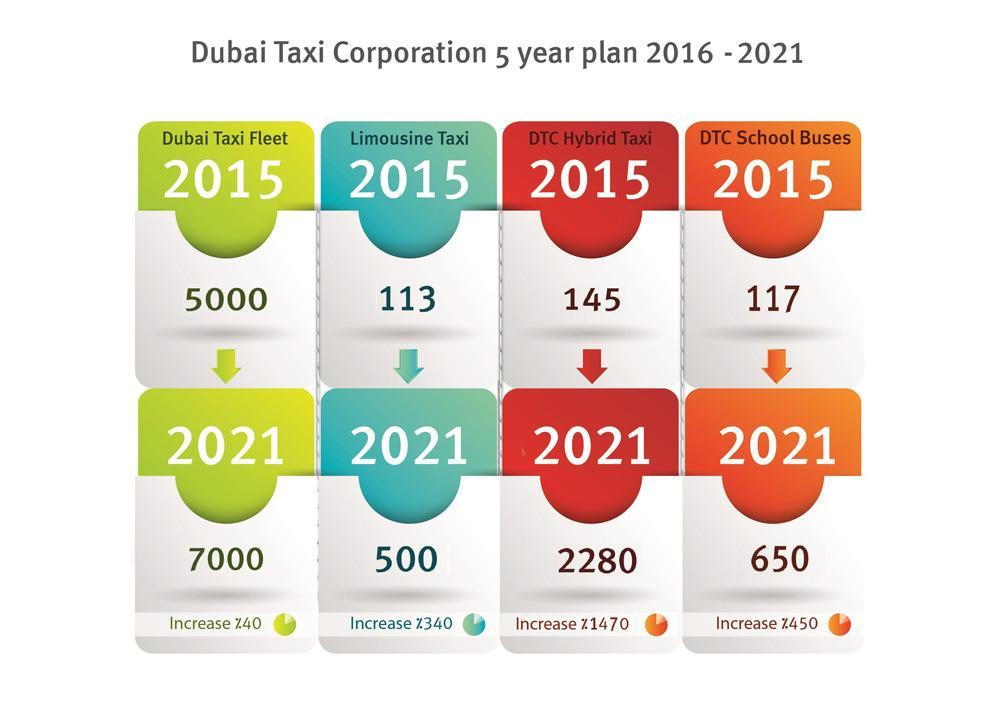For which Taxi highest charge increase will occur in 2021?
Answer the question with a short phrase. DTC Hybrid Taxi What is the rate of DTC Hybrid Taxi in 2015? 145 What will be the percentage increase of DTC School Buses rate by 2021? %450 For which Taxi second highest increase in charge will occur in 2021? DTC School Buses What will be the rate of Limousine Taxi in 2021? 500 What will be the percentage increase of Limousine Taxi rate by 2021? %340 What is the rate of Limousine Taxi in 2015? 113 How much the rate of DTC Hybrid taxi got increased from 2015 to 2021? 2,135 What will be rate of DTC Hybrid Taxi in 2021? 2280 